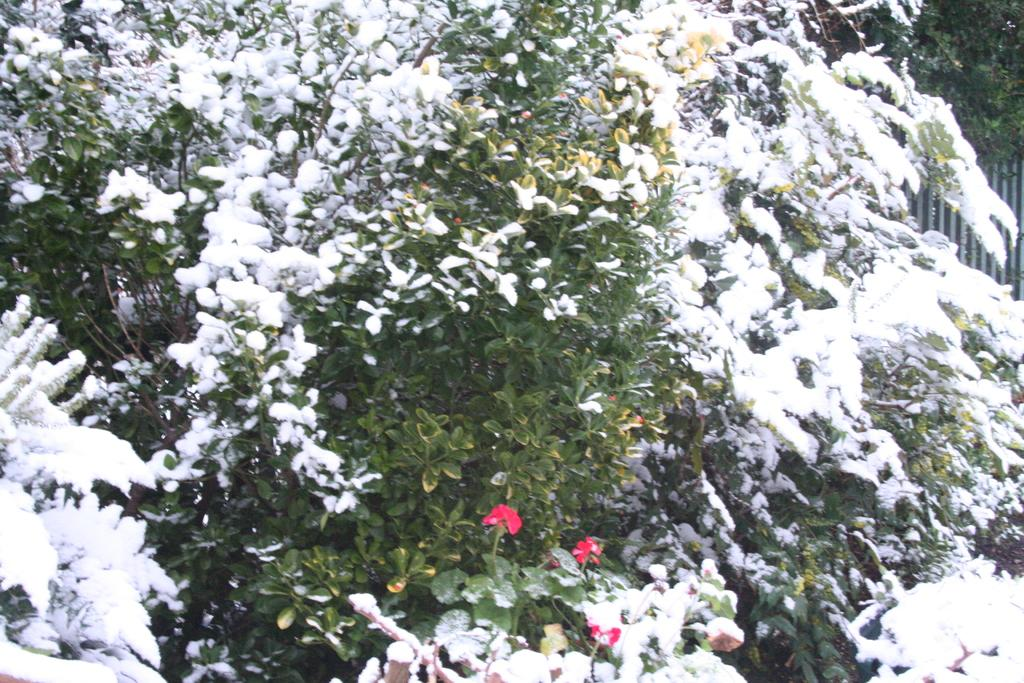What is the condition of the plants in the image? The plants in the image are covered with snow. What type of vegetation can be seen at the bottom of the image? There are flowers visible at the bottom of the image. What can be seen on the right side of the image in the background? There is an object and a tree in the background on the right side of the image. Can you describe the fight between the ant and the doll in the image? There is no fight between an ant and a doll present in the image. What type of doll is interacting with the flowers at the bottom of the image? There is no doll present in the image; it features plants covered with snow and flowers. 